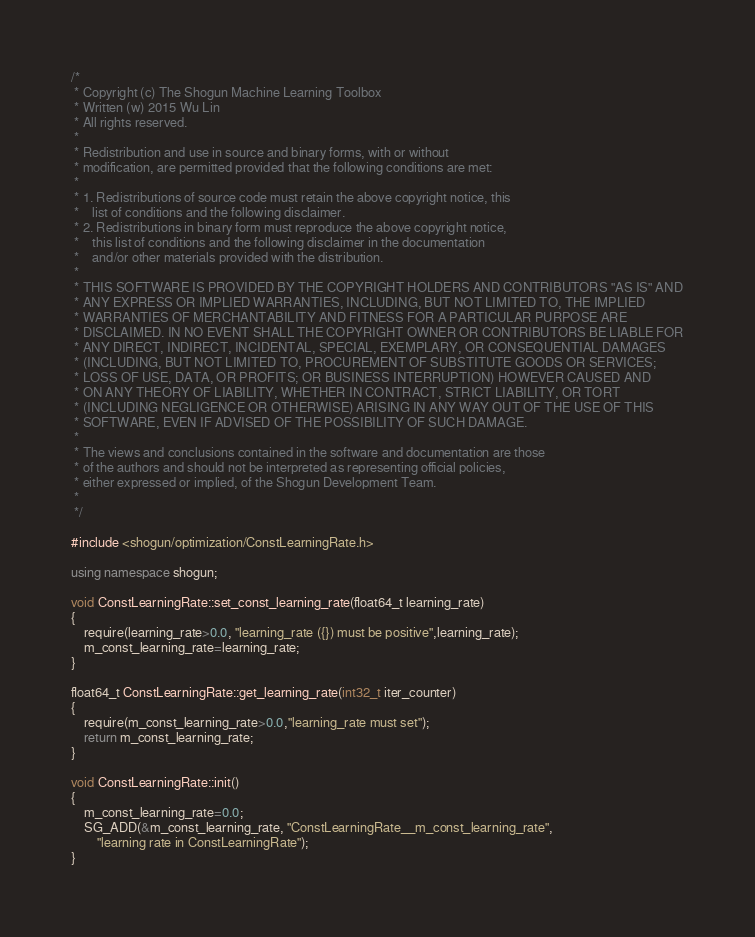<code> <loc_0><loc_0><loc_500><loc_500><_C++_>/*
 * Copyright (c) The Shogun Machine Learning Toolbox
 * Written (w) 2015 Wu Lin
 * All rights reserved.
 *
 * Redistribution and use in source and binary forms, with or without
 * modification, are permitted provided that the following conditions are met:
 *
 * 1. Redistributions of source code must retain the above copyright notice, this
 *    list of conditions and the following disclaimer.
 * 2. Redistributions in binary form must reproduce the above copyright notice,
 *    this list of conditions and the following disclaimer in the documentation
 *    and/or other materials provided with the distribution.
 *
 * THIS SOFTWARE IS PROVIDED BY THE COPYRIGHT HOLDERS AND CONTRIBUTORS "AS IS" AND
 * ANY EXPRESS OR IMPLIED WARRANTIES, INCLUDING, BUT NOT LIMITED TO, THE IMPLIED
 * WARRANTIES OF MERCHANTABILITY AND FITNESS FOR A PARTICULAR PURPOSE ARE
 * DISCLAIMED. IN NO EVENT SHALL THE COPYRIGHT OWNER OR CONTRIBUTORS BE LIABLE FOR
 * ANY DIRECT, INDIRECT, INCIDENTAL, SPECIAL, EXEMPLARY, OR CONSEQUENTIAL DAMAGES
 * (INCLUDING, BUT NOT LIMITED TO, PROCUREMENT OF SUBSTITUTE GOODS OR SERVICES;
 * LOSS OF USE, DATA, OR PROFITS; OR BUSINESS INTERRUPTION) HOWEVER CAUSED AND
 * ON ANY THEORY OF LIABILITY, WHETHER IN CONTRACT, STRICT LIABILITY, OR TORT
 * (INCLUDING NEGLIGENCE OR OTHERWISE) ARISING IN ANY WAY OUT OF THE USE OF THIS
 * SOFTWARE, EVEN IF ADVISED OF THE POSSIBILITY OF SUCH DAMAGE.
 *
 * The views and conclusions contained in the software and documentation are those
 * of the authors and should not be interpreted as representing official policies,
 * either expressed or implied, of the Shogun Development Team.
 *
 */

#include <shogun/optimization/ConstLearningRate.h>

using namespace shogun;

void ConstLearningRate::set_const_learning_rate(float64_t learning_rate)
{
	require(learning_rate>0.0, "learning_rate ({}) must be positive",learning_rate);
	m_const_learning_rate=learning_rate;
}

float64_t ConstLearningRate::get_learning_rate(int32_t iter_counter)
{
	require(m_const_learning_rate>0.0,"learning_rate must set");
	return m_const_learning_rate;
}

void ConstLearningRate::init()
{
	m_const_learning_rate=0.0;
	SG_ADD(&m_const_learning_rate, "ConstLearningRate__m_const_learning_rate",
		"learning rate in ConstLearningRate");
}
</code> 